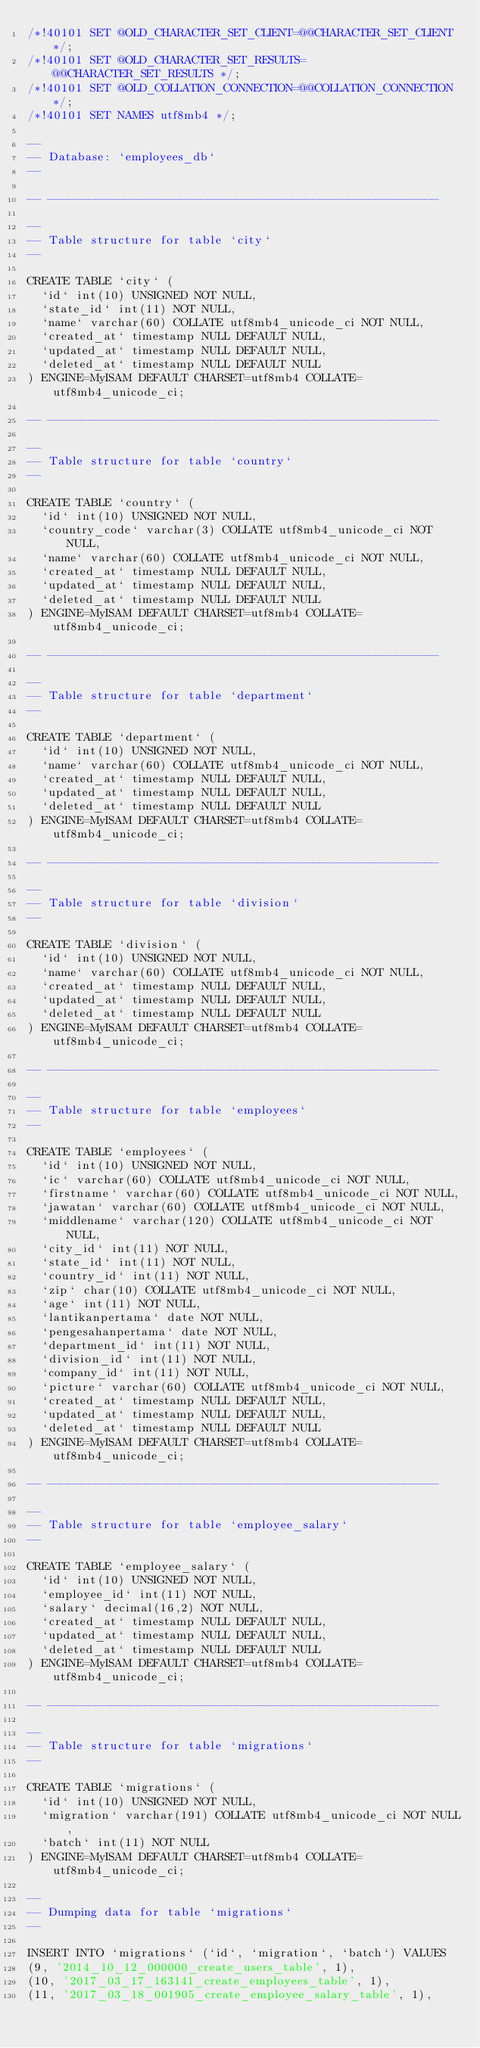Convert code to text. <code><loc_0><loc_0><loc_500><loc_500><_SQL_>/*!40101 SET @OLD_CHARACTER_SET_CLIENT=@@CHARACTER_SET_CLIENT */;
/*!40101 SET @OLD_CHARACTER_SET_RESULTS=@@CHARACTER_SET_RESULTS */;
/*!40101 SET @OLD_COLLATION_CONNECTION=@@COLLATION_CONNECTION */;
/*!40101 SET NAMES utf8mb4 */;

--
-- Database: `employees_db`
--

-- --------------------------------------------------------

--
-- Table structure for table `city`
--

CREATE TABLE `city` (
  `id` int(10) UNSIGNED NOT NULL,
  `state_id` int(11) NOT NULL,
  `name` varchar(60) COLLATE utf8mb4_unicode_ci NOT NULL,
  `created_at` timestamp NULL DEFAULT NULL,
  `updated_at` timestamp NULL DEFAULT NULL,
  `deleted_at` timestamp NULL DEFAULT NULL
) ENGINE=MyISAM DEFAULT CHARSET=utf8mb4 COLLATE=utf8mb4_unicode_ci;

-- --------------------------------------------------------

--
-- Table structure for table `country`
--

CREATE TABLE `country` (
  `id` int(10) UNSIGNED NOT NULL,
  `country_code` varchar(3) COLLATE utf8mb4_unicode_ci NOT NULL,
  `name` varchar(60) COLLATE utf8mb4_unicode_ci NOT NULL,
  `created_at` timestamp NULL DEFAULT NULL,
  `updated_at` timestamp NULL DEFAULT NULL,
  `deleted_at` timestamp NULL DEFAULT NULL
) ENGINE=MyISAM DEFAULT CHARSET=utf8mb4 COLLATE=utf8mb4_unicode_ci;

-- --------------------------------------------------------

--
-- Table structure for table `department`
--

CREATE TABLE `department` (
  `id` int(10) UNSIGNED NOT NULL,
  `name` varchar(60) COLLATE utf8mb4_unicode_ci NOT NULL,
  `created_at` timestamp NULL DEFAULT NULL,
  `updated_at` timestamp NULL DEFAULT NULL,
  `deleted_at` timestamp NULL DEFAULT NULL
) ENGINE=MyISAM DEFAULT CHARSET=utf8mb4 COLLATE=utf8mb4_unicode_ci;

-- --------------------------------------------------------

--
-- Table structure for table `division`
--

CREATE TABLE `division` (
  `id` int(10) UNSIGNED NOT NULL,
  `name` varchar(60) COLLATE utf8mb4_unicode_ci NOT NULL,
  `created_at` timestamp NULL DEFAULT NULL,
  `updated_at` timestamp NULL DEFAULT NULL,
  `deleted_at` timestamp NULL DEFAULT NULL
) ENGINE=MyISAM DEFAULT CHARSET=utf8mb4 COLLATE=utf8mb4_unicode_ci;

-- --------------------------------------------------------

--
-- Table structure for table `employees`
--

CREATE TABLE `employees` (
  `id` int(10) UNSIGNED NOT NULL,
  `ic` varchar(60) COLLATE utf8mb4_unicode_ci NOT NULL,
  `firstname` varchar(60) COLLATE utf8mb4_unicode_ci NOT NULL,
  `jawatan` varchar(60) COLLATE utf8mb4_unicode_ci NOT NULL,
  `middlename` varchar(120) COLLATE utf8mb4_unicode_ci NOT NULL,
  `city_id` int(11) NOT NULL,
  `state_id` int(11) NOT NULL,
  `country_id` int(11) NOT NULL,
  `zip` char(10) COLLATE utf8mb4_unicode_ci NOT NULL,
  `age` int(11) NOT NULL,
  `lantikanpertama` date NOT NULL,
  `pengesahanpertama` date NOT NULL,
  `department_id` int(11) NOT NULL,
  `division_id` int(11) NOT NULL,
  `company_id` int(11) NOT NULL,
  `picture` varchar(60) COLLATE utf8mb4_unicode_ci NOT NULL,
  `created_at` timestamp NULL DEFAULT NULL,
  `updated_at` timestamp NULL DEFAULT NULL,
  `deleted_at` timestamp NULL DEFAULT NULL
) ENGINE=MyISAM DEFAULT CHARSET=utf8mb4 COLLATE=utf8mb4_unicode_ci;

-- --------------------------------------------------------

--
-- Table structure for table `employee_salary`
--

CREATE TABLE `employee_salary` (
  `id` int(10) UNSIGNED NOT NULL,
  `employee_id` int(11) NOT NULL,
  `salary` decimal(16,2) NOT NULL,
  `created_at` timestamp NULL DEFAULT NULL,
  `updated_at` timestamp NULL DEFAULT NULL,
  `deleted_at` timestamp NULL DEFAULT NULL
) ENGINE=MyISAM DEFAULT CHARSET=utf8mb4 COLLATE=utf8mb4_unicode_ci;

-- --------------------------------------------------------

--
-- Table structure for table `migrations`
--

CREATE TABLE `migrations` (
  `id` int(10) UNSIGNED NOT NULL,
  `migration` varchar(191) COLLATE utf8mb4_unicode_ci NOT NULL,
  `batch` int(11) NOT NULL
) ENGINE=MyISAM DEFAULT CHARSET=utf8mb4 COLLATE=utf8mb4_unicode_ci;

--
-- Dumping data for table `migrations`
--

INSERT INTO `migrations` (`id`, `migration`, `batch`) VALUES
(9, '2014_10_12_000000_create_users_table', 1),
(10, '2017_03_17_163141_create_employees_table', 1),
(11, '2017_03_18_001905_create_employee_salary_table', 1),</code> 